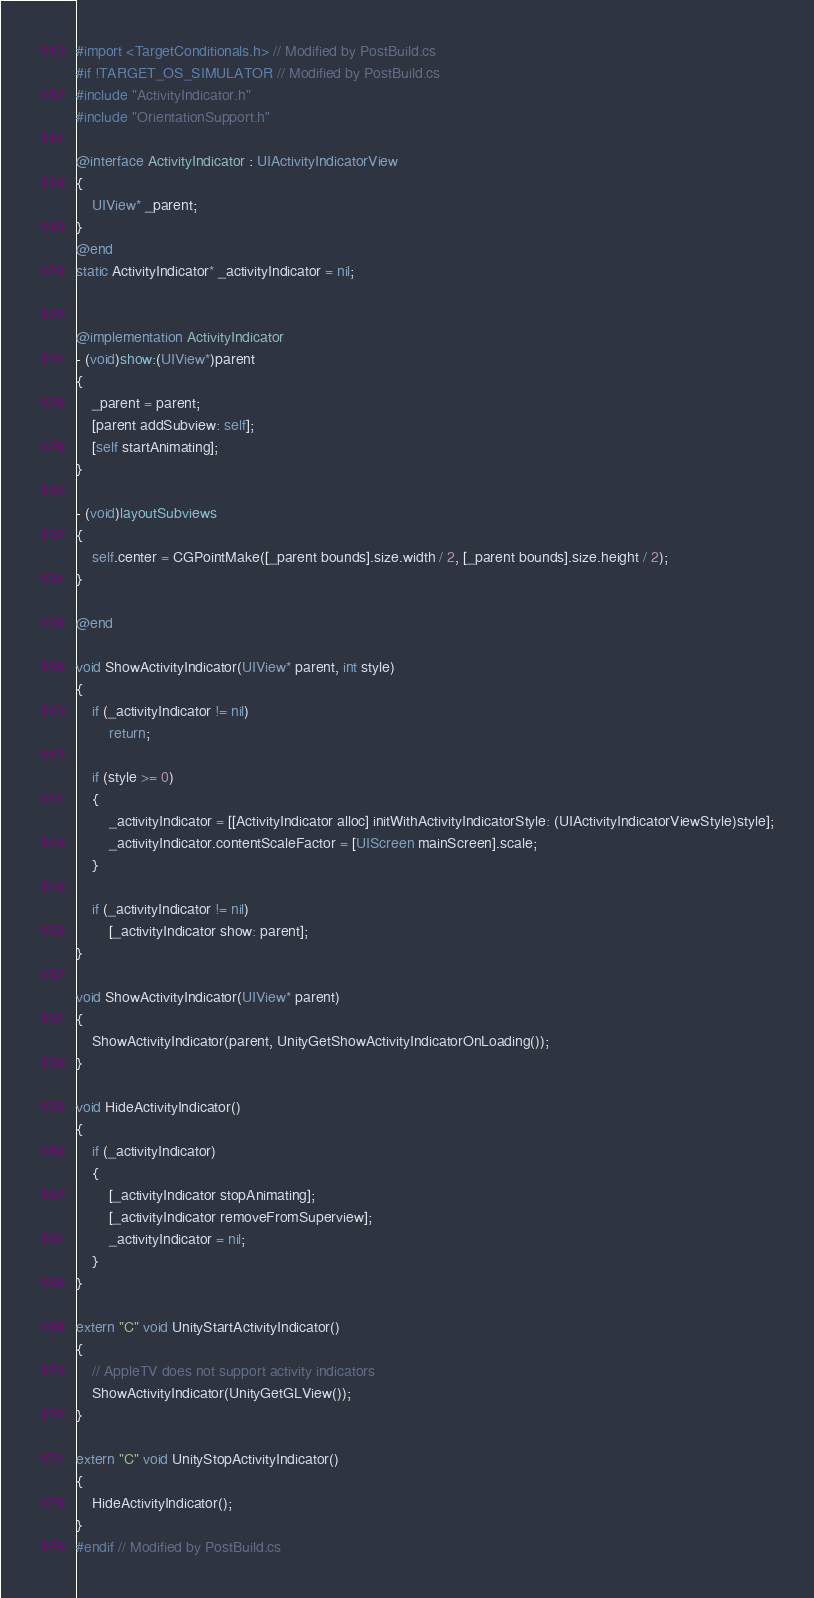<code> <loc_0><loc_0><loc_500><loc_500><_ObjectiveC_>#import <TargetConditionals.h> // Modified by PostBuild.cs
#if !TARGET_OS_SIMULATOR // Modified by PostBuild.cs
#include "ActivityIndicator.h"
#include "OrientationSupport.h"

@interface ActivityIndicator : UIActivityIndicatorView
{
    UIView* _parent;
}
@end
static ActivityIndicator* _activityIndicator = nil;


@implementation ActivityIndicator
- (void)show:(UIView*)parent
{
    _parent = parent;
    [parent addSubview: self];
    [self startAnimating];
}

- (void)layoutSubviews
{
    self.center = CGPointMake([_parent bounds].size.width / 2, [_parent bounds].size.height / 2);
}

@end

void ShowActivityIndicator(UIView* parent, int style)
{
    if (_activityIndicator != nil)
        return;

    if (style >= 0)
    {
        _activityIndicator = [[ActivityIndicator alloc] initWithActivityIndicatorStyle: (UIActivityIndicatorViewStyle)style];
        _activityIndicator.contentScaleFactor = [UIScreen mainScreen].scale;
    }

    if (_activityIndicator != nil)
        [_activityIndicator show: parent];
}

void ShowActivityIndicator(UIView* parent)
{
    ShowActivityIndicator(parent, UnityGetShowActivityIndicatorOnLoading());
}

void HideActivityIndicator()
{
    if (_activityIndicator)
    {
        [_activityIndicator stopAnimating];
        [_activityIndicator removeFromSuperview];
        _activityIndicator = nil;
    }
}

extern "C" void UnityStartActivityIndicator()
{
    // AppleTV does not support activity indicators
    ShowActivityIndicator(UnityGetGLView());
}

extern "C" void UnityStopActivityIndicator()
{
    HideActivityIndicator();
}
#endif // Modified by PostBuild.cs
</code> 